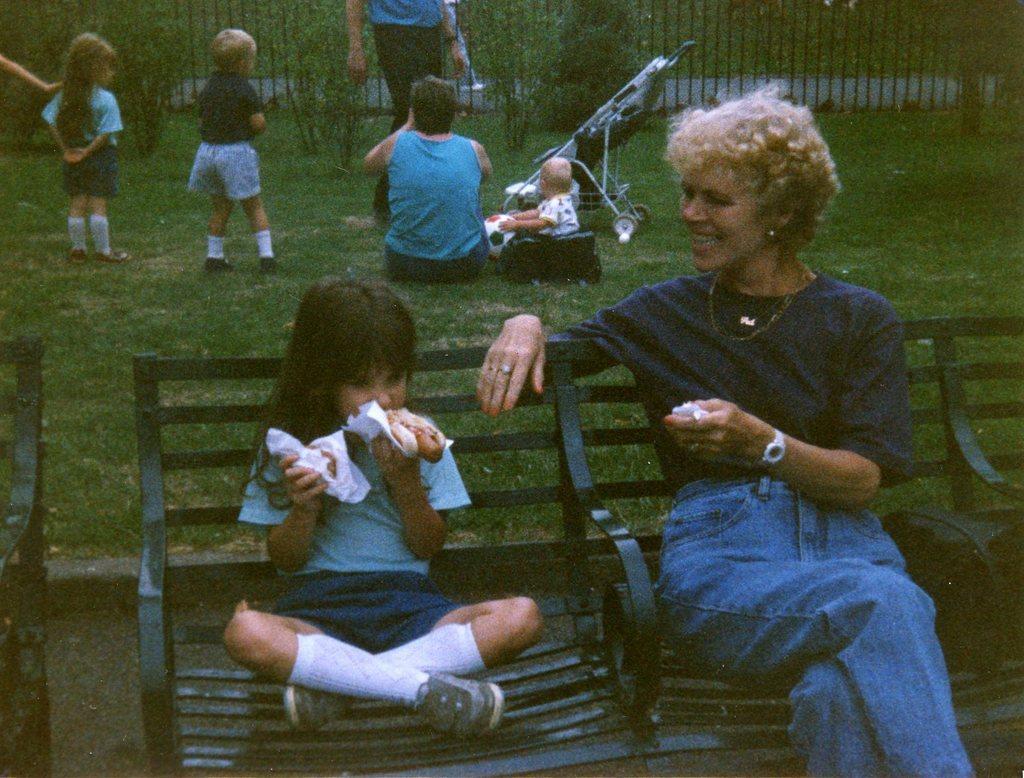How would you summarize this image in a sentence or two? In the image there are two people sitting on a bench and behind them there are kids and other people on a grass surface, behind them there is a fencing. 